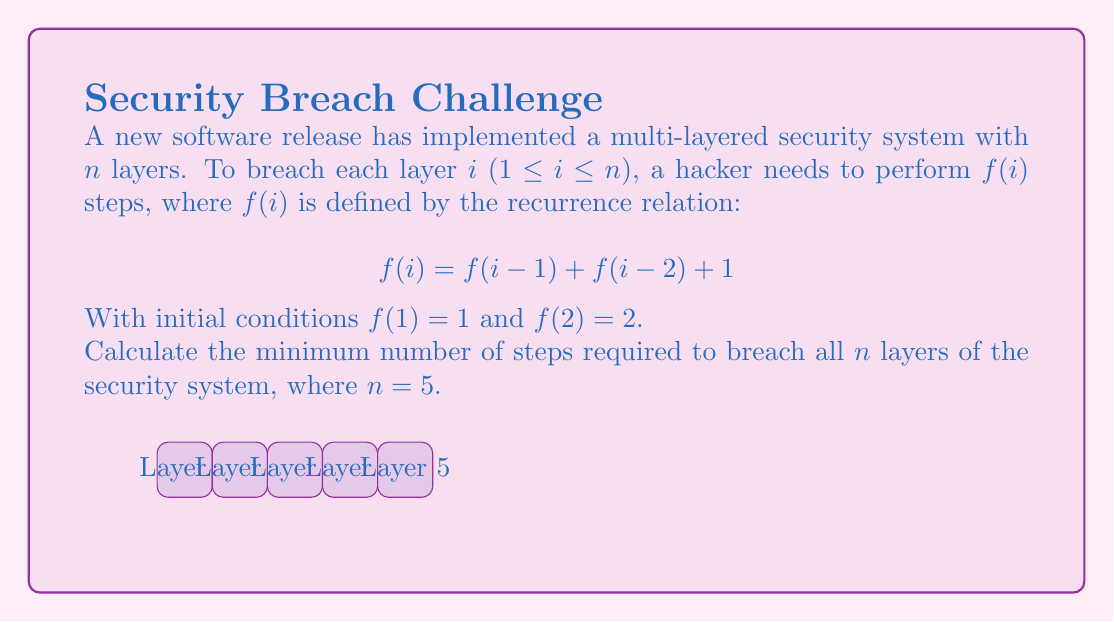Provide a solution to this math problem. To solve this problem, we need to use the given recurrence relation to calculate f(i) for i = 1 to 5, and then sum up all the values.

Step 1: Calculate f(1) and f(2) using the given initial conditions.
f(1) = 1
f(2) = 2

Step 2: Calculate f(3) using the recurrence relation.
f(3) = f(2) + f(1) + 1 = 2 + 1 + 1 = 4

Step 3: Calculate f(4) using the recurrence relation.
f(4) = f(3) + f(2) + 1 = 4 + 2 + 1 = 7

Step 4: Calculate f(5) using the recurrence relation.
f(5) = f(4) + f(3) + 1 = 7 + 4 + 1 = 12

Step 5: Sum up all the values to get the total number of steps.
Total steps = f(1) + f(2) + f(3) + f(4) + f(5)
            = 1 + 2 + 4 + 7 + 12
            = 26

Therefore, the minimum number of steps required to breach all 5 layers of the security system is 26.
Answer: 26 steps 